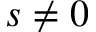<formula> <loc_0><loc_0><loc_500><loc_500>s \neq 0</formula> 